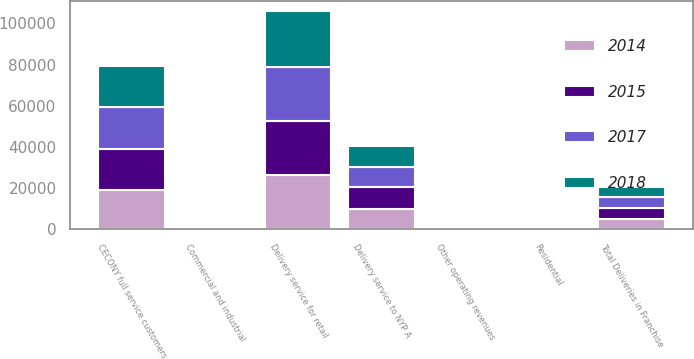Convert chart to OTSL. <chart><loc_0><loc_0><loc_500><loc_500><stacked_bar_chart><ecel><fcel>CECONY full service customers<fcel>Delivery service for retail<fcel>Delivery service to NYP A<fcel>Total Deliveries in Franchise<fcel>Other operating revenues<fcel>Residential<fcel>Commercial and industrial<nl><fcel>2015<fcel>19757<fcel>26221<fcel>10325<fcel>5139.5<fcel>143<fcel>28.9<fcel>22.1<nl><fcel>2017<fcel>20206<fcel>26662<fcel>10147<fcel>5139.5<fcel>101<fcel>26.3<fcel>20.6<nl><fcel>2018<fcel>19886<fcel>26813<fcel>10046<fcel>5139.5<fcel>324<fcel>24.9<fcel>19.1<nl><fcel>2014<fcel>19227<fcel>26136<fcel>9955<fcel>5139.5<fcel>289<fcel>25.3<fcel>19.7<nl></chart> 